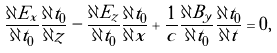Convert formula to latex. <formula><loc_0><loc_0><loc_500><loc_500>\frac { \partial E _ { x } } { \partial t _ { 0 } } \frac { \partial t _ { 0 } } { \partial z } - \frac { \partial E _ { z } } { \partial t _ { 0 } } \frac { \partial t _ { 0 } } { \partial x } + \frac { 1 } { c } \frac { \partial B _ { y } } { \partial t _ { 0 } } \frac { \partial t _ { 0 } } { \partial t } = 0 ,</formula> 